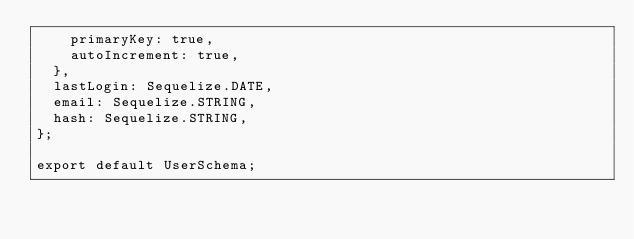<code> <loc_0><loc_0><loc_500><loc_500><_JavaScript_>    primaryKey: true,
    autoIncrement: true,
  },
  lastLogin: Sequelize.DATE,
  email: Sequelize.STRING,
  hash: Sequelize.STRING,
};

export default UserSchema;
</code> 